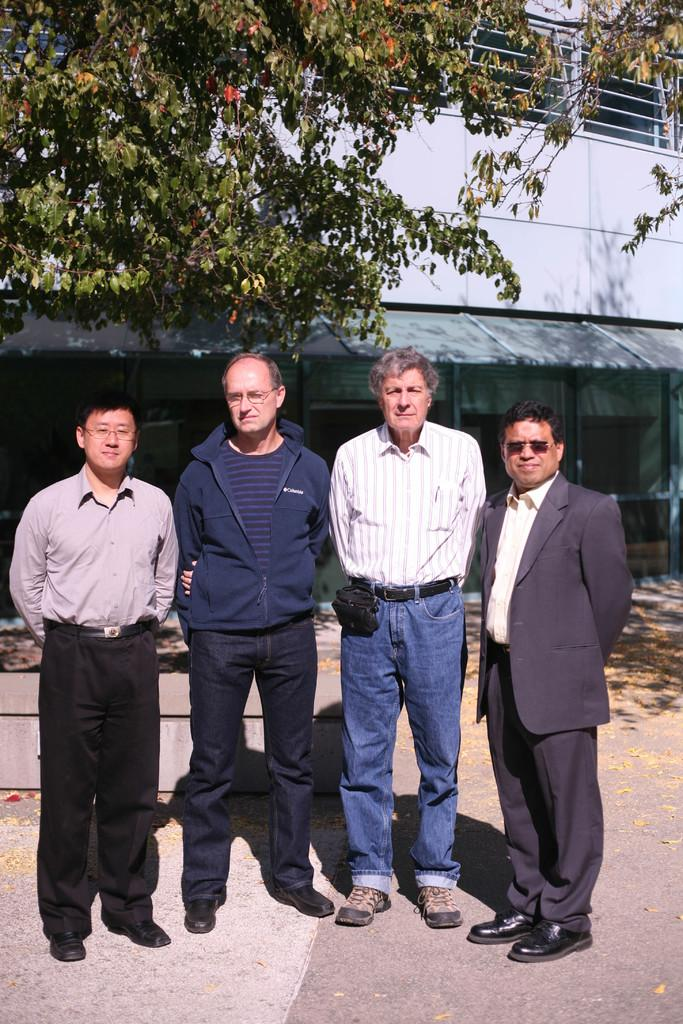What are the people in the image doing? The people in the image are standing on the road. What can be seen in the background of the image? There is a building and trees in the background. Can you describe the person on the right side of the image? The person on the right side of the image is wearing a blazer and goggles. What type of birthday celebration is happening in the image? There is no indication of a birthday celebration in the image. How does the earthquake affect the people in the image? There is no earthquake present in the image, so its effects cannot be observed. 